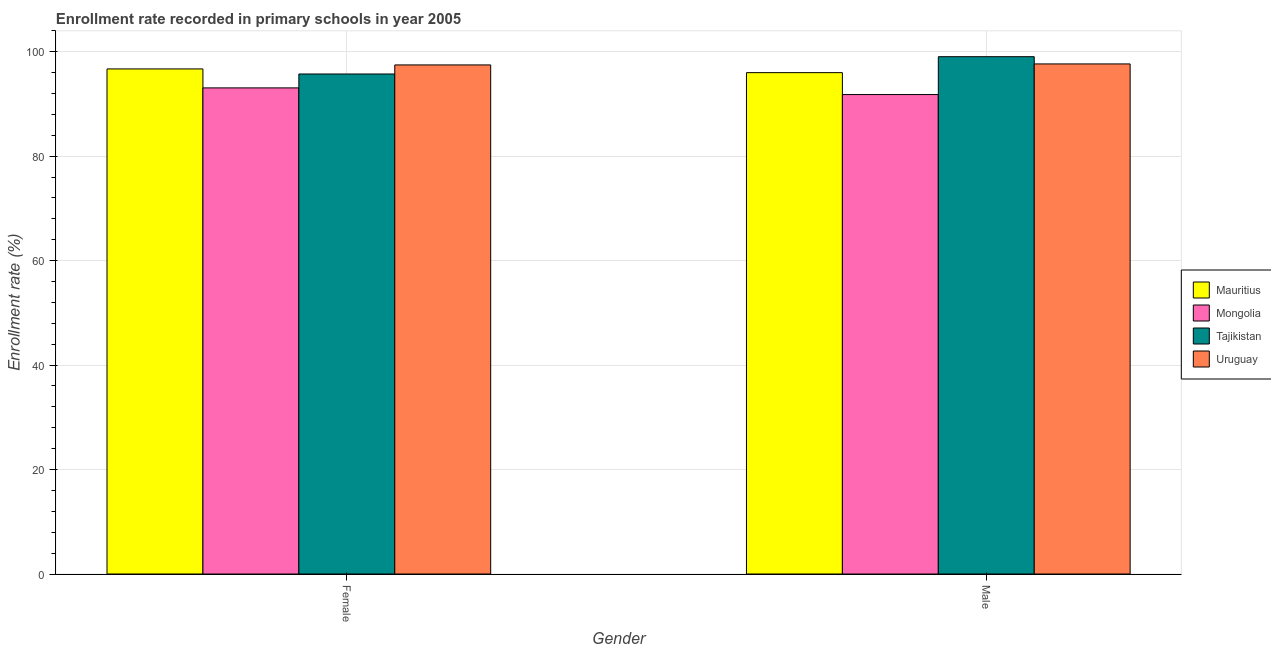How many groups of bars are there?
Your answer should be compact. 2. Are the number of bars per tick equal to the number of legend labels?
Offer a very short reply. Yes. How many bars are there on the 1st tick from the left?
Offer a terse response. 4. How many bars are there on the 2nd tick from the right?
Offer a terse response. 4. What is the enrollment rate of female students in Mauritius?
Ensure brevity in your answer.  96.71. Across all countries, what is the maximum enrollment rate of female students?
Your answer should be compact. 97.48. Across all countries, what is the minimum enrollment rate of male students?
Make the answer very short. 91.81. In which country was the enrollment rate of male students maximum?
Your answer should be compact. Tajikistan. In which country was the enrollment rate of male students minimum?
Keep it short and to the point. Mongolia. What is the total enrollment rate of female students in the graph?
Make the answer very short. 383.01. What is the difference between the enrollment rate of male students in Mongolia and that in Tajikistan?
Offer a very short reply. -7.25. What is the difference between the enrollment rate of male students in Uruguay and the enrollment rate of female students in Tajikistan?
Ensure brevity in your answer.  1.93. What is the average enrollment rate of female students per country?
Keep it short and to the point. 95.75. What is the difference between the enrollment rate of female students and enrollment rate of male students in Tajikistan?
Offer a terse response. -3.31. What is the ratio of the enrollment rate of female students in Mauritius to that in Uruguay?
Provide a short and direct response. 0.99. Is the enrollment rate of male students in Tajikistan less than that in Mauritius?
Your response must be concise. No. In how many countries, is the enrollment rate of female students greater than the average enrollment rate of female students taken over all countries?
Give a very brief answer. 2. What does the 4th bar from the left in Female represents?
Your answer should be compact. Uruguay. What does the 4th bar from the right in Male represents?
Ensure brevity in your answer.  Mauritius. How many bars are there?
Your answer should be very brief. 8. What is the difference between two consecutive major ticks on the Y-axis?
Your answer should be compact. 20. Does the graph contain any zero values?
Your answer should be very brief. No. Where does the legend appear in the graph?
Offer a terse response. Center right. How many legend labels are there?
Offer a very short reply. 4. What is the title of the graph?
Ensure brevity in your answer.  Enrollment rate recorded in primary schools in year 2005. What is the label or title of the Y-axis?
Your answer should be very brief. Enrollment rate (%). What is the Enrollment rate (%) of Mauritius in Female?
Your answer should be very brief. 96.71. What is the Enrollment rate (%) of Mongolia in Female?
Ensure brevity in your answer.  93.08. What is the Enrollment rate (%) of Tajikistan in Female?
Your answer should be very brief. 95.74. What is the Enrollment rate (%) of Uruguay in Female?
Keep it short and to the point. 97.48. What is the Enrollment rate (%) in Mauritius in Male?
Offer a terse response. 96. What is the Enrollment rate (%) of Mongolia in Male?
Ensure brevity in your answer.  91.81. What is the Enrollment rate (%) in Tajikistan in Male?
Give a very brief answer. 99.05. What is the Enrollment rate (%) of Uruguay in Male?
Give a very brief answer. 97.67. Across all Gender, what is the maximum Enrollment rate (%) of Mauritius?
Keep it short and to the point. 96.71. Across all Gender, what is the maximum Enrollment rate (%) of Mongolia?
Keep it short and to the point. 93.08. Across all Gender, what is the maximum Enrollment rate (%) of Tajikistan?
Provide a short and direct response. 99.05. Across all Gender, what is the maximum Enrollment rate (%) in Uruguay?
Your answer should be very brief. 97.67. Across all Gender, what is the minimum Enrollment rate (%) of Mauritius?
Offer a terse response. 96. Across all Gender, what is the minimum Enrollment rate (%) in Mongolia?
Ensure brevity in your answer.  91.81. Across all Gender, what is the minimum Enrollment rate (%) of Tajikistan?
Offer a very short reply. 95.74. Across all Gender, what is the minimum Enrollment rate (%) in Uruguay?
Provide a short and direct response. 97.48. What is the total Enrollment rate (%) of Mauritius in the graph?
Provide a short and direct response. 192.71. What is the total Enrollment rate (%) in Mongolia in the graph?
Offer a very short reply. 184.88. What is the total Enrollment rate (%) in Tajikistan in the graph?
Provide a short and direct response. 194.8. What is the total Enrollment rate (%) of Uruguay in the graph?
Provide a short and direct response. 195.15. What is the difference between the Enrollment rate (%) in Mauritius in Female and that in Male?
Your response must be concise. 0.71. What is the difference between the Enrollment rate (%) of Mongolia in Female and that in Male?
Offer a very short reply. 1.27. What is the difference between the Enrollment rate (%) of Tajikistan in Female and that in Male?
Give a very brief answer. -3.31. What is the difference between the Enrollment rate (%) of Uruguay in Female and that in Male?
Make the answer very short. -0.19. What is the difference between the Enrollment rate (%) in Mauritius in Female and the Enrollment rate (%) in Mongolia in Male?
Keep it short and to the point. 4.91. What is the difference between the Enrollment rate (%) in Mauritius in Female and the Enrollment rate (%) in Tajikistan in Male?
Offer a terse response. -2.34. What is the difference between the Enrollment rate (%) of Mauritius in Female and the Enrollment rate (%) of Uruguay in Male?
Provide a short and direct response. -0.96. What is the difference between the Enrollment rate (%) of Mongolia in Female and the Enrollment rate (%) of Tajikistan in Male?
Provide a succinct answer. -5.98. What is the difference between the Enrollment rate (%) of Mongolia in Female and the Enrollment rate (%) of Uruguay in Male?
Keep it short and to the point. -4.59. What is the difference between the Enrollment rate (%) in Tajikistan in Female and the Enrollment rate (%) in Uruguay in Male?
Your response must be concise. -1.93. What is the average Enrollment rate (%) in Mauritius per Gender?
Ensure brevity in your answer.  96.36. What is the average Enrollment rate (%) of Mongolia per Gender?
Provide a short and direct response. 92.44. What is the average Enrollment rate (%) of Tajikistan per Gender?
Make the answer very short. 97.4. What is the average Enrollment rate (%) of Uruguay per Gender?
Give a very brief answer. 97.57. What is the difference between the Enrollment rate (%) in Mauritius and Enrollment rate (%) in Mongolia in Female?
Make the answer very short. 3.63. What is the difference between the Enrollment rate (%) of Mauritius and Enrollment rate (%) of Tajikistan in Female?
Make the answer very short. 0.97. What is the difference between the Enrollment rate (%) of Mauritius and Enrollment rate (%) of Uruguay in Female?
Offer a very short reply. -0.77. What is the difference between the Enrollment rate (%) of Mongolia and Enrollment rate (%) of Tajikistan in Female?
Your answer should be very brief. -2.66. What is the difference between the Enrollment rate (%) of Mongolia and Enrollment rate (%) of Uruguay in Female?
Ensure brevity in your answer.  -4.4. What is the difference between the Enrollment rate (%) of Tajikistan and Enrollment rate (%) of Uruguay in Female?
Your response must be concise. -1.74. What is the difference between the Enrollment rate (%) in Mauritius and Enrollment rate (%) in Mongolia in Male?
Make the answer very short. 4.19. What is the difference between the Enrollment rate (%) of Mauritius and Enrollment rate (%) of Tajikistan in Male?
Keep it short and to the point. -3.06. What is the difference between the Enrollment rate (%) in Mauritius and Enrollment rate (%) in Uruguay in Male?
Your answer should be compact. -1.67. What is the difference between the Enrollment rate (%) of Mongolia and Enrollment rate (%) of Tajikistan in Male?
Make the answer very short. -7.25. What is the difference between the Enrollment rate (%) in Mongolia and Enrollment rate (%) in Uruguay in Male?
Make the answer very short. -5.86. What is the difference between the Enrollment rate (%) of Tajikistan and Enrollment rate (%) of Uruguay in Male?
Your response must be concise. 1.39. What is the ratio of the Enrollment rate (%) in Mauritius in Female to that in Male?
Provide a succinct answer. 1.01. What is the ratio of the Enrollment rate (%) in Mongolia in Female to that in Male?
Keep it short and to the point. 1.01. What is the ratio of the Enrollment rate (%) in Tajikistan in Female to that in Male?
Make the answer very short. 0.97. What is the ratio of the Enrollment rate (%) in Uruguay in Female to that in Male?
Provide a succinct answer. 1. What is the difference between the highest and the second highest Enrollment rate (%) in Mauritius?
Your response must be concise. 0.71. What is the difference between the highest and the second highest Enrollment rate (%) in Mongolia?
Give a very brief answer. 1.27. What is the difference between the highest and the second highest Enrollment rate (%) of Tajikistan?
Ensure brevity in your answer.  3.31. What is the difference between the highest and the second highest Enrollment rate (%) in Uruguay?
Provide a succinct answer. 0.19. What is the difference between the highest and the lowest Enrollment rate (%) in Mauritius?
Make the answer very short. 0.71. What is the difference between the highest and the lowest Enrollment rate (%) of Mongolia?
Keep it short and to the point. 1.27. What is the difference between the highest and the lowest Enrollment rate (%) in Tajikistan?
Ensure brevity in your answer.  3.31. What is the difference between the highest and the lowest Enrollment rate (%) of Uruguay?
Offer a terse response. 0.19. 